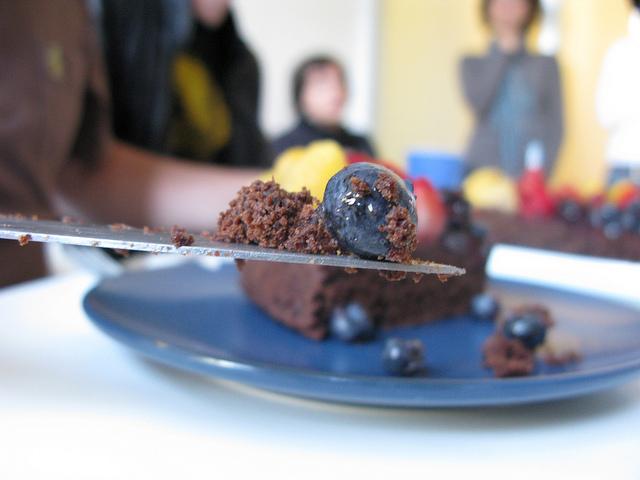How many people are in the background?
Give a very brief answer. 4. Is this a big knife?
Be succinct. Yes. How many blueberries are on the plate?
Quick response, please. 4. 